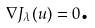Convert formula to latex. <formula><loc_0><loc_0><loc_500><loc_500>\nabla J _ { \lambda } ( u ) = 0 \text {.}</formula> 